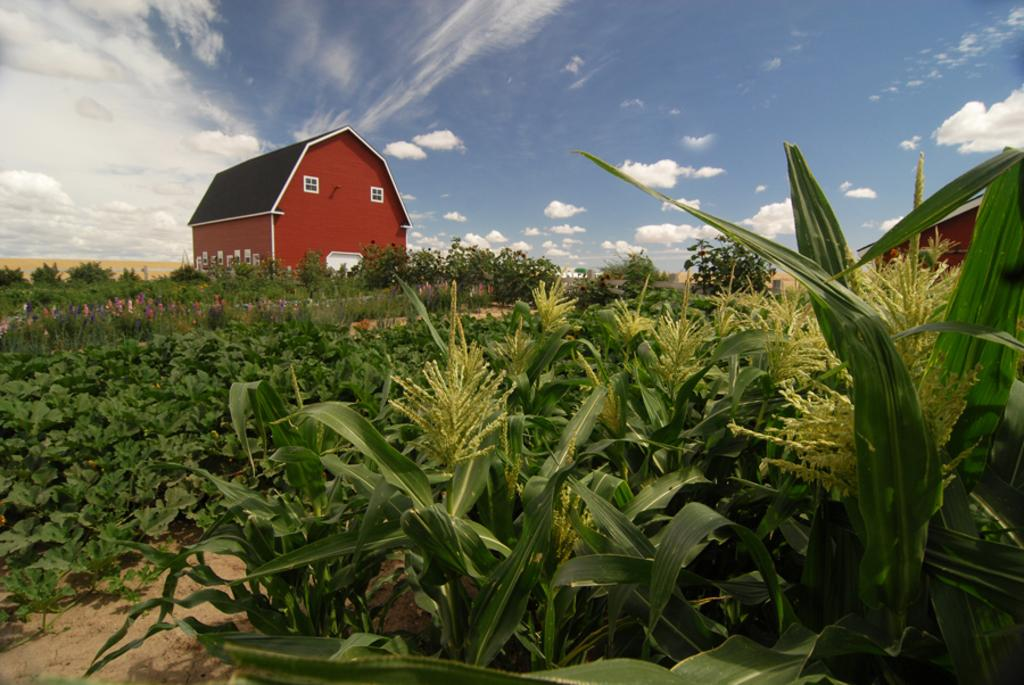What type of vegetation is present on the ground in the image? There are creepers on the ground in the image. What other types of vegetation can be seen in the image? There are plants and trees in the image. What structure is visible in the image? There is a building in the image. What part of the natural environment is visible in the image? The sky is visible in the image, and clouds are present in the sky. What type of wood is the uncle using to build the calculator in the image? There is no uncle, calculator, or wood present in the image. 